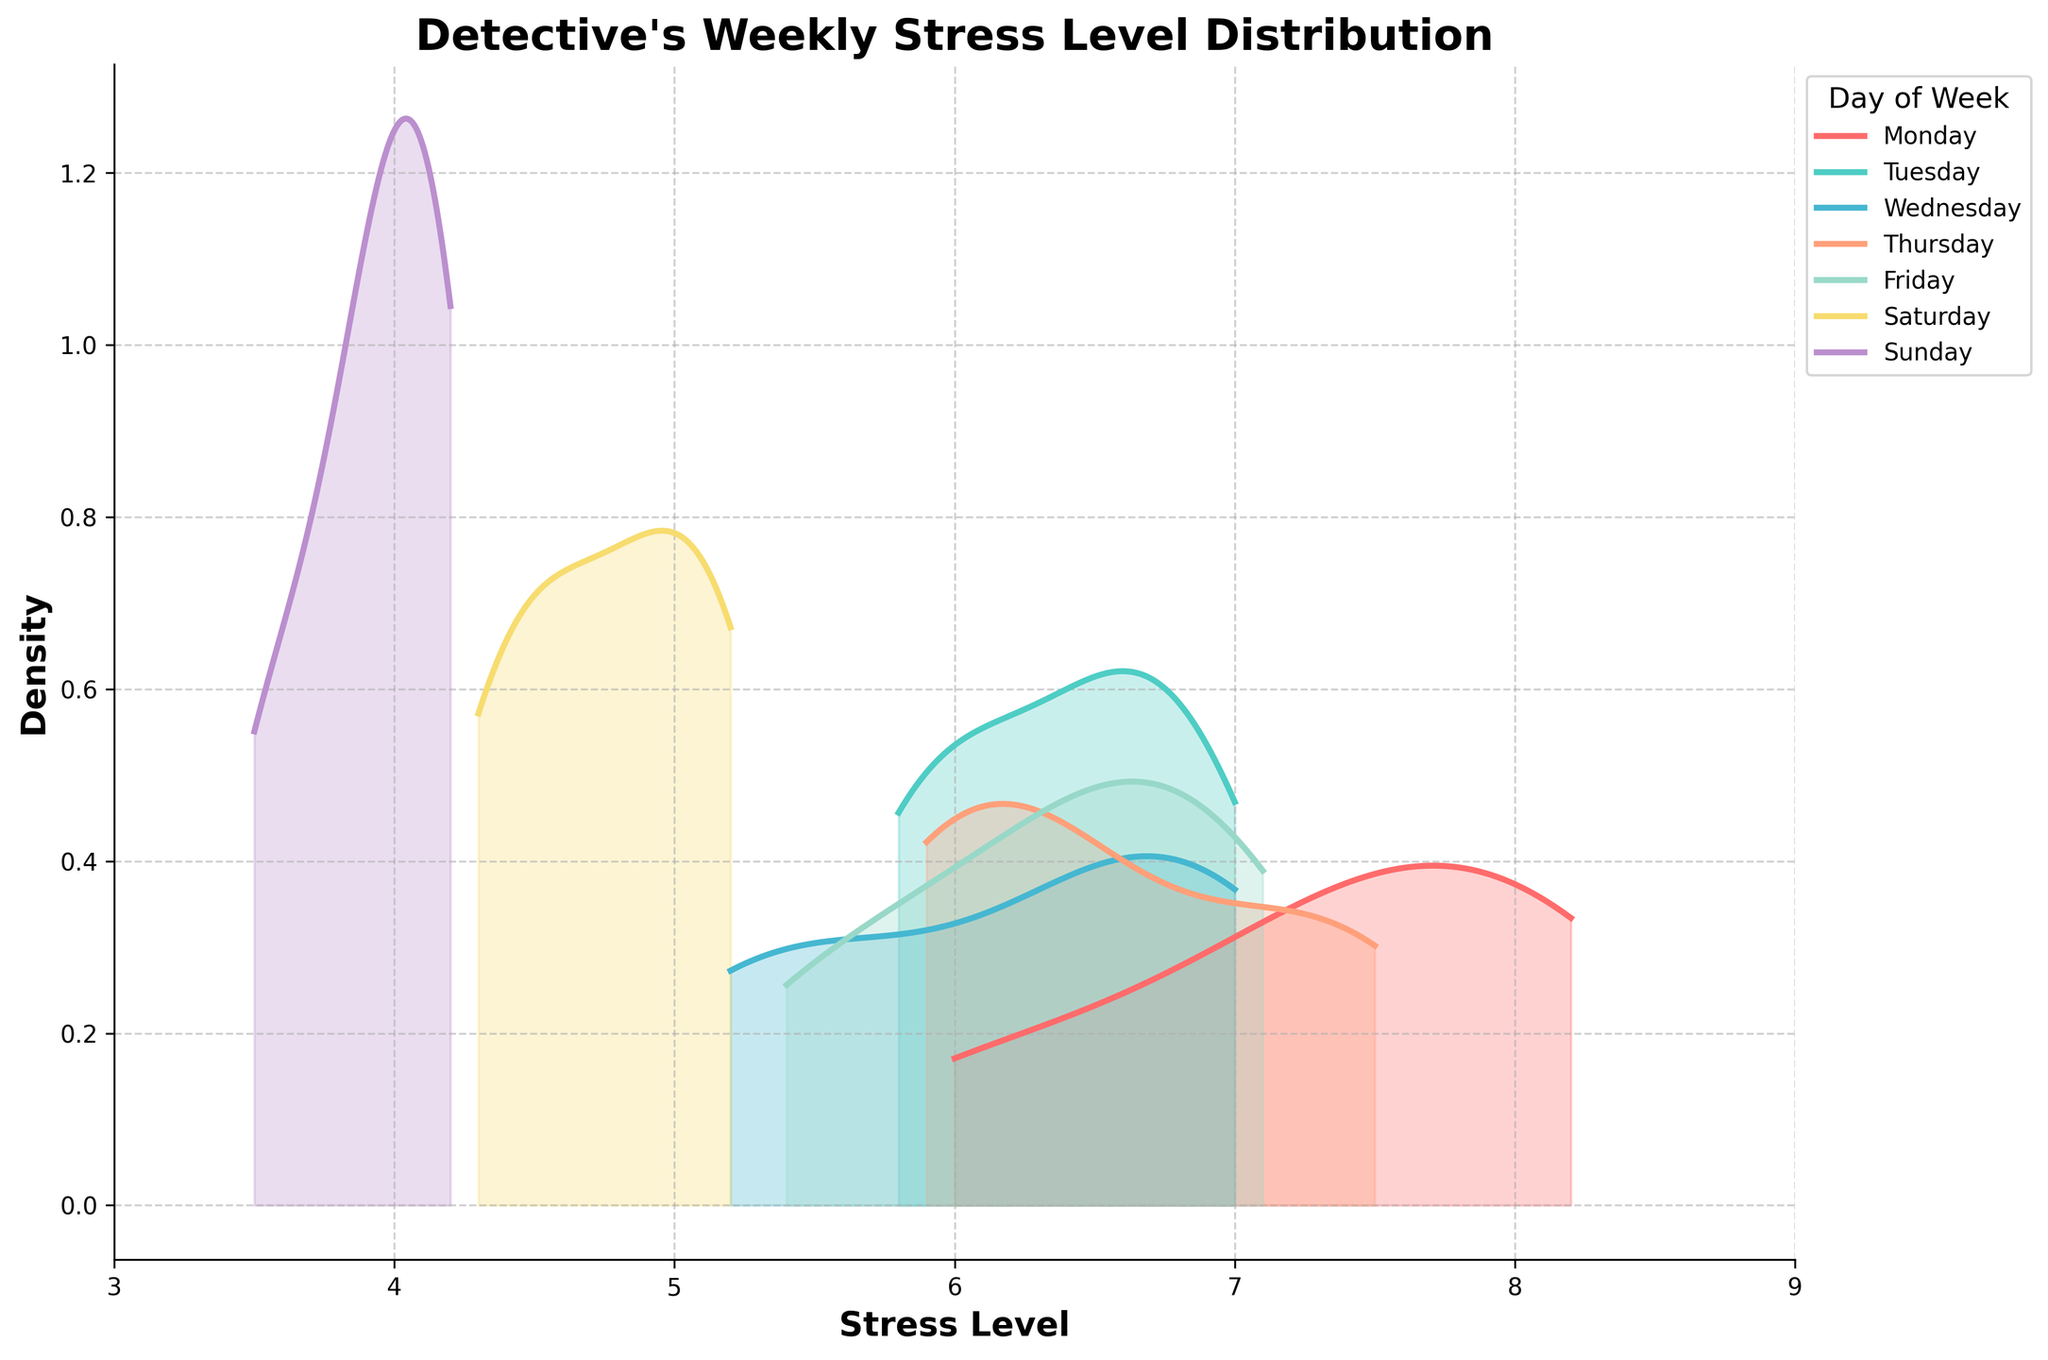What's the title of the figure? The title of the figure is displayed prominently at the top of the plot.
Answer: Detective's Weekly Stress Level Distribution What is the range of the x-axis? The x-axis range is indicated at the bottom of the plot, starting from the minimum to the maximum value.
Answer: 3 to 9 Which day has the lowest peak in stress level density? By examining each day's density curve, look for the day with the lowest maximum density value on the y-axis.
Answer: Sunday How does the stress level distribution on Tuesday compare to Monday? Compare the density curves for both days. Tuesday's curve is more spread out than Monday's, indicating more variability.
Answer: More spread out Which day shows the highest density for stress levels around 4? Observe the curves and identify which day has the highest peak at or around the 4 mark on the x-axis.
Answer: Sunday Do any days have overlapping density curves? Examine if any density curves for different days overlap with each other at any point.
Answer: Yes What is the color associated with Thursday's density curve? Each day's curve is color-coded, and the legend box specifies the corresponding color for Thursday.
Answer: Amber Is there a significant difference in stress levels between weekends and weekdays? Compare the density peaks of the curves for Saturday and Sunday with those from Monday to Friday. Weekends have lower stress levels with density curves peaking towards the lower end of the stress scale.
Answer: Yes Which day's stress level density curve appears the most symmetrical? Assess the shapes of the density curves to see which one looks most symmetrical around its peak.
Answer: Wednesday What could be inferred about stress levels between Thursday and Friday based on the curves? Compare the shapes and peaks of Thursday's and Friday's curves. Thursday has slightly higher variability but similar average stress levels to Friday.
Answer: Similar stress levels 